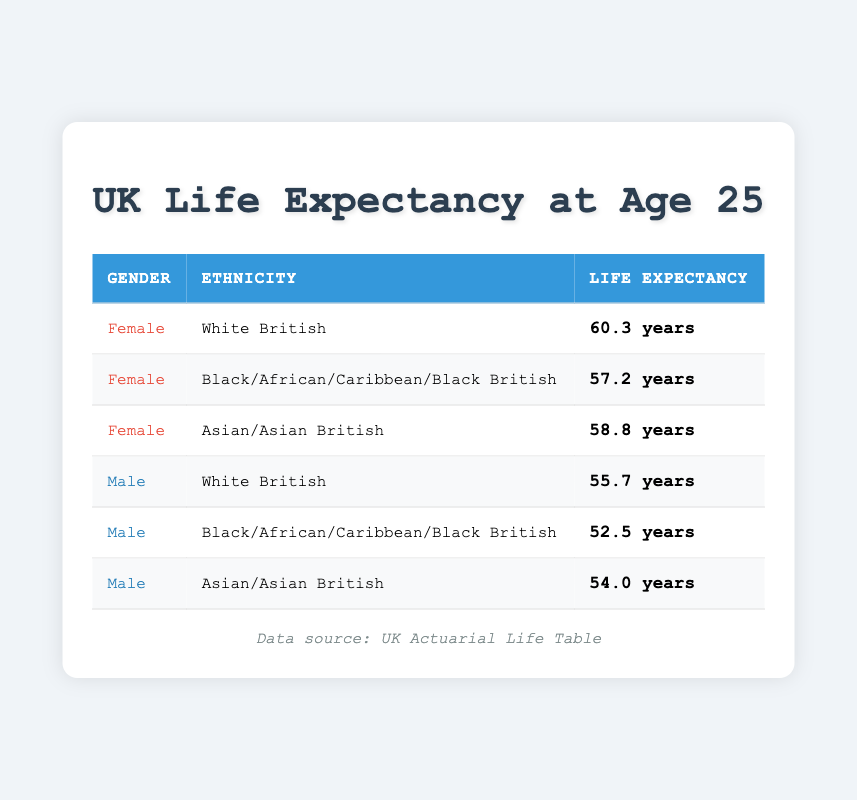What is the life expectancy for a female who is White British? Looking at the table, the life expectancy for a female who is White British is listed as 60.3 years.
Answer: 60.3 years What is the life expectancy for a male who is Black/African/Caribbean/Black British? According to the table, the life expectancy for a male in this demographic is 52.5 years.
Answer: 52.5 years Is the life expectancy for Asian/Asian British females higher than for White British females? From the table, the life expectancy for Asian/Asian British females is 58.8 years, while for White British females it is 60.3 years. Since 58.8 is less than 60.3, the statement is false.
Answer: No What is the difference in life expectancy between White British females and Black/African/Caribbean/Black British males? The life expectancy for White British females is 60.3 years, and for Black/African/Caribbean/Black British males, it is 52.5 years. The difference is calculated as 60.3 - 52.5 = 7.8 years.
Answer: 7.8 years What is the average life expectancy for all the males listed in the table? The life expectancies for males are 55.7 (White British), 52.5 (Black/African/Caribbean/Black British), and 54.0 (Asian/Asian British). The average is calculated by summing these values: 55.7 + 52.5 + 54.0 = 162.2, then dividing by the number of males (3), resulting in an average of 162.2 / 3 = 54.07 years.
Answer: 54.07 years Is the life expectancy for females higher than that of males across the board? Female life expectancies are 60.3, 57.2, and 58.8 years, while males have life expectancies of 55.7, 52.5, and 54.0 years. All female values are greater than the respective male values, confirming the statement is true.
Answer: Yes What demographic has the lowest life expectancy at age 25? Reviewing the table, the lowest life expectancy is for males of Black/African/Caribbean/Black British ethnicity, which is 52.5 years.
Answer: Males of Black/African/Caribbean/Black British ethnicity What is the total life expectancy of all females listed in the table? The life expectancies for females are 60.3 (White British), 57.2 (Black/African/Caribbean/Black British), and 58.8 (Asian/Asian British). Adding these values gives: 60.3 + 57.2 + 58.8 = 176.3 years.
Answer: 176.3 years 